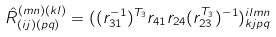<formula> <loc_0><loc_0><loc_500><loc_500>\hat { R } _ { ( i j ) ( p q ) } ^ { ( m n ) ( k l ) } = ( ( r _ { 3 1 } ^ { - 1 } ) ^ { T _ { 3 } } r _ { 4 1 } r _ { 2 4 } ( r _ { 2 3 } ^ { T _ { 3 } } ) ^ { - 1 } ) _ { k j p q } ^ { i l m n }</formula> 